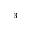Convert formula to latex. <formula><loc_0><loc_0><loc_500><loc_500>_ { 3 }</formula> 